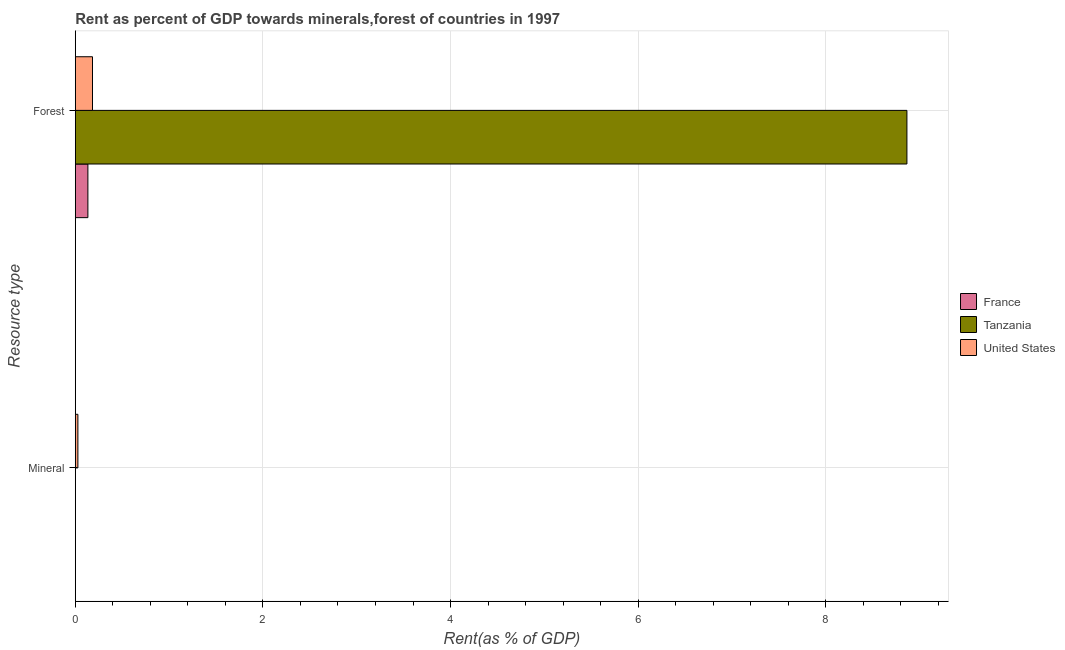How many groups of bars are there?
Your response must be concise. 2. Are the number of bars per tick equal to the number of legend labels?
Ensure brevity in your answer.  Yes. How many bars are there on the 1st tick from the top?
Make the answer very short. 3. What is the label of the 1st group of bars from the top?
Make the answer very short. Forest. What is the mineral rent in Tanzania?
Ensure brevity in your answer.  0. Across all countries, what is the maximum mineral rent?
Ensure brevity in your answer.  0.03. Across all countries, what is the minimum forest rent?
Offer a very short reply. 0.13. In which country was the mineral rent minimum?
Your answer should be very brief. France. What is the total forest rent in the graph?
Your response must be concise. 9.18. What is the difference between the mineral rent in United States and that in France?
Provide a succinct answer. 0.03. What is the difference between the mineral rent in Tanzania and the forest rent in France?
Offer a very short reply. -0.13. What is the average forest rent per country?
Make the answer very short. 3.06. What is the difference between the mineral rent and forest rent in United States?
Make the answer very short. -0.16. In how many countries, is the forest rent greater than 3.2 %?
Offer a very short reply. 1. What is the ratio of the forest rent in France to that in United States?
Provide a succinct answer. 0.73. Is the mineral rent in Tanzania less than that in United States?
Provide a succinct answer. Yes. In how many countries, is the mineral rent greater than the average mineral rent taken over all countries?
Your response must be concise. 1. What does the 2nd bar from the top in Forest represents?
Your answer should be very brief. Tanzania. What does the 2nd bar from the bottom in Forest represents?
Provide a short and direct response. Tanzania. How many bars are there?
Offer a terse response. 6. How many countries are there in the graph?
Your answer should be compact. 3. Are the values on the major ticks of X-axis written in scientific E-notation?
Keep it short and to the point. No. How are the legend labels stacked?
Make the answer very short. Vertical. What is the title of the graph?
Provide a short and direct response. Rent as percent of GDP towards minerals,forest of countries in 1997. Does "Least developed countries" appear as one of the legend labels in the graph?
Provide a succinct answer. No. What is the label or title of the X-axis?
Your answer should be compact. Rent(as % of GDP). What is the label or title of the Y-axis?
Offer a very short reply. Resource type. What is the Rent(as % of GDP) in France in Mineral?
Your response must be concise. 0. What is the Rent(as % of GDP) of Tanzania in Mineral?
Give a very brief answer. 0. What is the Rent(as % of GDP) in United States in Mineral?
Provide a short and direct response. 0.03. What is the Rent(as % of GDP) of France in Forest?
Ensure brevity in your answer.  0.13. What is the Rent(as % of GDP) in Tanzania in Forest?
Give a very brief answer. 8.86. What is the Rent(as % of GDP) in United States in Forest?
Ensure brevity in your answer.  0.18. Across all Resource type, what is the maximum Rent(as % of GDP) of France?
Ensure brevity in your answer.  0.13. Across all Resource type, what is the maximum Rent(as % of GDP) in Tanzania?
Ensure brevity in your answer.  8.86. Across all Resource type, what is the maximum Rent(as % of GDP) in United States?
Provide a short and direct response. 0.18. Across all Resource type, what is the minimum Rent(as % of GDP) of France?
Offer a terse response. 0. Across all Resource type, what is the minimum Rent(as % of GDP) of Tanzania?
Provide a succinct answer. 0. Across all Resource type, what is the minimum Rent(as % of GDP) of United States?
Your response must be concise. 0.03. What is the total Rent(as % of GDP) of France in the graph?
Keep it short and to the point. 0.13. What is the total Rent(as % of GDP) in Tanzania in the graph?
Ensure brevity in your answer.  8.86. What is the total Rent(as % of GDP) in United States in the graph?
Your answer should be compact. 0.21. What is the difference between the Rent(as % of GDP) of France in Mineral and that in Forest?
Your answer should be very brief. -0.13. What is the difference between the Rent(as % of GDP) in Tanzania in Mineral and that in Forest?
Provide a succinct answer. -8.86. What is the difference between the Rent(as % of GDP) of United States in Mineral and that in Forest?
Offer a very short reply. -0.16. What is the difference between the Rent(as % of GDP) of France in Mineral and the Rent(as % of GDP) of Tanzania in Forest?
Make the answer very short. -8.86. What is the difference between the Rent(as % of GDP) in France in Mineral and the Rent(as % of GDP) in United States in Forest?
Your response must be concise. -0.18. What is the difference between the Rent(as % of GDP) in Tanzania in Mineral and the Rent(as % of GDP) in United States in Forest?
Offer a terse response. -0.18. What is the average Rent(as % of GDP) of France per Resource type?
Offer a very short reply. 0.07. What is the average Rent(as % of GDP) of Tanzania per Resource type?
Keep it short and to the point. 4.43. What is the average Rent(as % of GDP) in United States per Resource type?
Your answer should be very brief. 0.11. What is the difference between the Rent(as % of GDP) of France and Rent(as % of GDP) of Tanzania in Mineral?
Make the answer very short. -0. What is the difference between the Rent(as % of GDP) in France and Rent(as % of GDP) in United States in Mineral?
Your answer should be very brief. -0.03. What is the difference between the Rent(as % of GDP) in Tanzania and Rent(as % of GDP) in United States in Mineral?
Your answer should be very brief. -0.03. What is the difference between the Rent(as % of GDP) in France and Rent(as % of GDP) in Tanzania in Forest?
Provide a succinct answer. -8.73. What is the difference between the Rent(as % of GDP) of France and Rent(as % of GDP) of United States in Forest?
Offer a terse response. -0.05. What is the difference between the Rent(as % of GDP) of Tanzania and Rent(as % of GDP) of United States in Forest?
Provide a short and direct response. 8.68. What is the ratio of the Rent(as % of GDP) of France in Mineral to that in Forest?
Provide a succinct answer. 0. What is the ratio of the Rent(as % of GDP) in Tanzania in Mineral to that in Forest?
Provide a succinct answer. 0. What is the ratio of the Rent(as % of GDP) of United States in Mineral to that in Forest?
Provide a short and direct response. 0.15. What is the difference between the highest and the second highest Rent(as % of GDP) in France?
Keep it short and to the point. 0.13. What is the difference between the highest and the second highest Rent(as % of GDP) in Tanzania?
Ensure brevity in your answer.  8.86. What is the difference between the highest and the second highest Rent(as % of GDP) in United States?
Make the answer very short. 0.16. What is the difference between the highest and the lowest Rent(as % of GDP) of France?
Your response must be concise. 0.13. What is the difference between the highest and the lowest Rent(as % of GDP) of Tanzania?
Keep it short and to the point. 8.86. What is the difference between the highest and the lowest Rent(as % of GDP) in United States?
Your response must be concise. 0.16. 